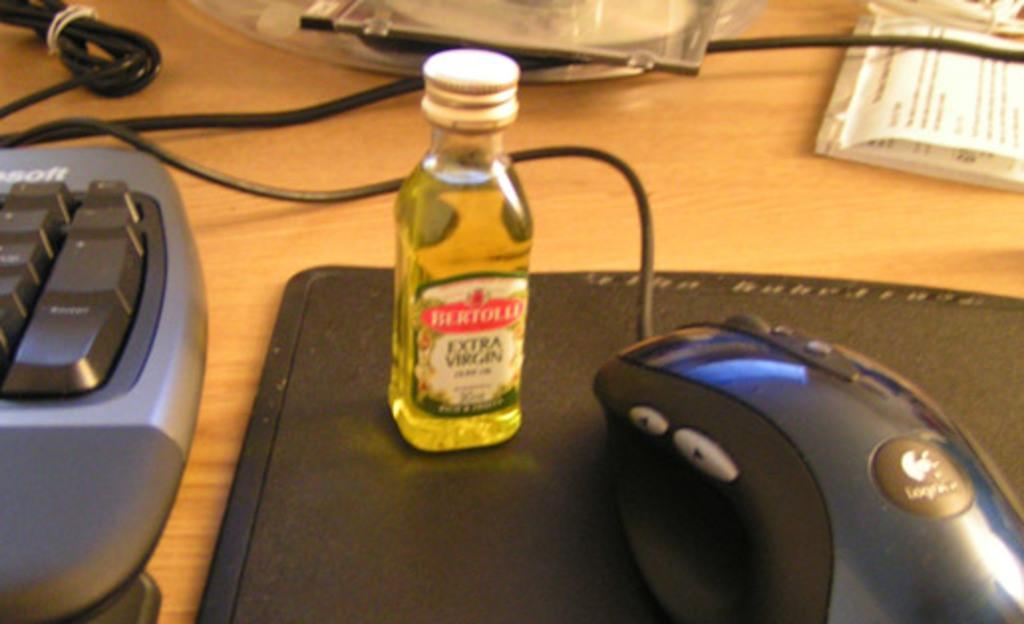What type of furniture is in the image? There is a table in the image. What electronic devices are on the table? There is a mouse and a keyboard on the table. What type of storage device is on the table? There is a disc on the table. What is used for writing or drawing on the table? Notes are on the table. What is used for holding liquid on the table? There is a bottle with some liquid on the table. What is used for positioning the mouse on the table? There is a mouse pad on the table. What other objects are on the table? There are cables, other objects, and possibly more items that are not specified. What type of lettuce is being served for lunch on the table? There is no lettuce or lunch being served on the table in the image. The table contains a mouse, keyboard, disc, notes, bottle with liquid, and a mouse pad, along with cables and other objects. 